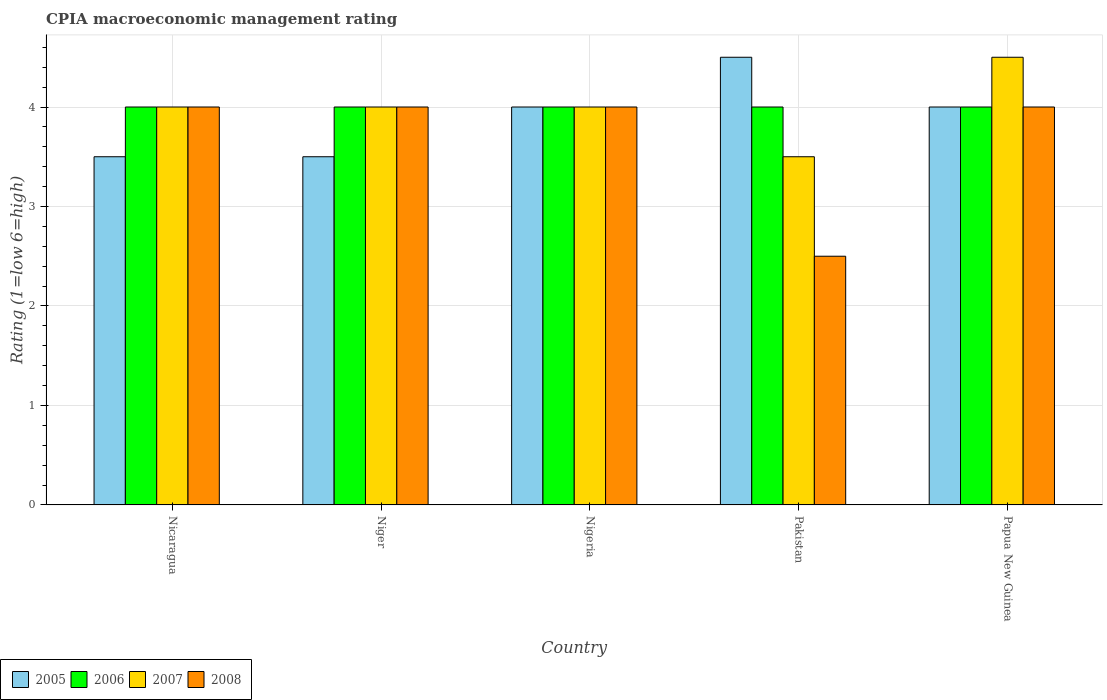How many different coloured bars are there?
Your answer should be compact. 4. How many groups of bars are there?
Provide a succinct answer. 5. Are the number of bars per tick equal to the number of legend labels?
Give a very brief answer. Yes. Are the number of bars on each tick of the X-axis equal?
Your answer should be very brief. Yes. How many bars are there on the 5th tick from the right?
Offer a terse response. 4. What is the label of the 5th group of bars from the left?
Offer a very short reply. Papua New Guinea. In which country was the CPIA rating in 2006 maximum?
Provide a succinct answer. Nicaragua. In how many countries, is the CPIA rating in 2006 greater than 4.4?
Ensure brevity in your answer.  0. What is the ratio of the CPIA rating in 2008 in Nicaragua to that in Papua New Guinea?
Provide a short and direct response. 1. What is the difference between the highest and the second highest CPIA rating in 2005?
Your answer should be compact. 0.5. What is the difference between the highest and the lowest CPIA rating in 2007?
Ensure brevity in your answer.  1. What does the 3rd bar from the left in Pakistan represents?
Give a very brief answer. 2007. Are all the bars in the graph horizontal?
Keep it short and to the point. No. Are the values on the major ticks of Y-axis written in scientific E-notation?
Your answer should be compact. No. How are the legend labels stacked?
Your answer should be compact. Horizontal. What is the title of the graph?
Provide a short and direct response. CPIA macroeconomic management rating. Does "1995" appear as one of the legend labels in the graph?
Offer a very short reply. No. What is the label or title of the Y-axis?
Provide a succinct answer. Rating (1=low 6=high). What is the Rating (1=low 6=high) in 2005 in Nicaragua?
Ensure brevity in your answer.  3.5. What is the Rating (1=low 6=high) of 2007 in Nicaragua?
Ensure brevity in your answer.  4. What is the Rating (1=low 6=high) of 2008 in Nicaragua?
Give a very brief answer. 4. What is the Rating (1=low 6=high) of 2007 in Niger?
Offer a terse response. 4. What is the Rating (1=low 6=high) in 2006 in Nigeria?
Keep it short and to the point. 4. What is the Rating (1=low 6=high) in 2007 in Nigeria?
Make the answer very short. 4. What is the Rating (1=low 6=high) in 2008 in Nigeria?
Your answer should be very brief. 4. What is the Rating (1=low 6=high) of 2005 in Pakistan?
Offer a terse response. 4.5. What is the Rating (1=low 6=high) of 2006 in Pakistan?
Offer a very short reply. 4. What is the Rating (1=low 6=high) in 2007 in Pakistan?
Make the answer very short. 3.5. What is the Rating (1=low 6=high) of 2007 in Papua New Guinea?
Provide a short and direct response. 4.5. Across all countries, what is the maximum Rating (1=low 6=high) in 2008?
Provide a short and direct response. 4. Across all countries, what is the minimum Rating (1=low 6=high) of 2005?
Your response must be concise. 3.5. Across all countries, what is the minimum Rating (1=low 6=high) of 2006?
Offer a terse response. 4. Across all countries, what is the minimum Rating (1=low 6=high) in 2008?
Offer a terse response. 2.5. What is the total Rating (1=low 6=high) in 2005 in the graph?
Keep it short and to the point. 19.5. What is the total Rating (1=low 6=high) in 2007 in the graph?
Keep it short and to the point. 20. What is the total Rating (1=low 6=high) of 2008 in the graph?
Make the answer very short. 18.5. What is the difference between the Rating (1=low 6=high) of 2005 in Nicaragua and that in Niger?
Offer a very short reply. 0. What is the difference between the Rating (1=low 6=high) in 2006 in Nicaragua and that in Niger?
Keep it short and to the point. 0. What is the difference between the Rating (1=low 6=high) of 2007 in Nicaragua and that in Niger?
Ensure brevity in your answer.  0. What is the difference between the Rating (1=low 6=high) of 2008 in Nicaragua and that in Niger?
Keep it short and to the point. 0. What is the difference between the Rating (1=low 6=high) in 2005 in Nicaragua and that in Nigeria?
Ensure brevity in your answer.  -0.5. What is the difference between the Rating (1=low 6=high) in 2006 in Nicaragua and that in Nigeria?
Make the answer very short. 0. What is the difference between the Rating (1=low 6=high) in 2007 in Nicaragua and that in Nigeria?
Keep it short and to the point. 0. What is the difference between the Rating (1=low 6=high) in 2008 in Nicaragua and that in Nigeria?
Give a very brief answer. 0. What is the difference between the Rating (1=low 6=high) in 2006 in Nicaragua and that in Papua New Guinea?
Offer a terse response. 0. What is the difference between the Rating (1=low 6=high) of 2008 in Niger and that in Pakistan?
Offer a very short reply. 1.5. What is the difference between the Rating (1=low 6=high) of 2005 in Niger and that in Papua New Guinea?
Give a very brief answer. -0.5. What is the difference between the Rating (1=low 6=high) in 2008 in Niger and that in Papua New Guinea?
Make the answer very short. 0. What is the difference between the Rating (1=low 6=high) of 2006 in Nigeria and that in Papua New Guinea?
Provide a succinct answer. 0. What is the difference between the Rating (1=low 6=high) of 2005 in Pakistan and that in Papua New Guinea?
Ensure brevity in your answer.  0.5. What is the difference between the Rating (1=low 6=high) of 2006 in Pakistan and that in Papua New Guinea?
Provide a succinct answer. 0. What is the difference between the Rating (1=low 6=high) of 2007 in Pakistan and that in Papua New Guinea?
Keep it short and to the point. -1. What is the difference between the Rating (1=low 6=high) in 2008 in Pakistan and that in Papua New Guinea?
Give a very brief answer. -1.5. What is the difference between the Rating (1=low 6=high) in 2005 in Nicaragua and the Rating (1=low 6=high) in 2006 in Niger?
Offer a very short reply. -0.5. What is the difference between the Rating (1=low 6=high) in 2005 in Nicaragua and the Rating (1=low 6=high) in 2008 in Niger?
Ensure brevity in your answer.  -0.5. What is the difference between the Rating (1=low 6=high) of 2006 in Nicaragua and the Rating (1=low 6=high) of 2008 in Niger?
Make the answer very short. 0. What is the difference between the Rating (1=low 6=high) of 2007 in Nicaragua and the Rating (1=low 6=high) of 2008 in Niger?
Your response must be concise. 0. What is the difference between the Rating (1=low 6=high) of 2005 in Nicaragua and the Rating (1=low 6=high) of 2006 in Pakistan?
Give a very brief answer. -0.5. What is the difference between the Rating (1=low 6=high) in 2005 in Nicaragua and the Rating (1=low 6=high) in 2008 in Pakistan?
Provide a short and direct response. 1. What is the difference between the Rating (1=low 6=high) of 2006 in Nicaragua and the Rating (1=low 6=high) of 2007 in Pakistan?
Give a very brief answer. 0.5. What is the difference between the Rating (1=low 6=high) of 2006 in Nicaragua and the Rating (1=low 6=high) of 2008 in Pakistan?
Give a very brief answer. 1.5. What is the difference between the Rating (1=low 6=high) of 2007 in Nicaragua and the Rating (1=low 6=high) of 2008 in Pakistan?
Provide a short and direct response. 1.5. What is the difference between the Rating (1=low 6=high) of 2005 in Nicaragua and the Rating (1=low 6=high) of 2007 in Papua New Guinea?
Provide a short and direct response. -1. What is the difference between the Rating (1=low 6=high) in 2005 in Nicaragua and the Rating (1=low 6=high) in 2008 in Papua New Guinea?
Offer a very short reply. -0.5. What is the difference between the Rating (1=low 6=high) in 2006 in Nicaragua and the Rating (1=low 6=high) in 2007 in Papua New Guinea?
Make the answer very short. -0.5. What is the difference between the Rating (1=low 6=high) of 2007 in Nicaragua and the Rating (1=low 6=high) of 2008 in Papua New Guinea?
Your answer should be compact. 0. What is the difference between the Rating (1=low 6=high) in 2005 in Niger and the Rating (1=low 6=high) in 2007 in Nigeria?
Your answer should be very brief. -0.5. What is the difference between the Rating (1=low 6=high) in 2005 in Niger and the Rating (1=low 6=high) in 2008 in Nigeria?
Offer a terse response. -0.5. What is the difference between the Rating (1=low 6=high) of 2006 in Niger and the Rating (1=low 6=high) of 2008 in Nigeria?
Provide a short and direct response. 0. What is the difference between the Rating (1=low 6=high) of 2007 in Niger and the Rating (1=low 6=high) of 2008 in Nigeria?
Your answer should be compact. 0. What is the difference between the Rating (1=low 6=high) of 2005 in Niger and the Rating (1=low 6=high) of 2007 in Pakistan?
Ensure brevity in your answer.  0. What is the difference between the Rating (1=low 6=high) in 2005 in Niger and the Rating (1=low 6=high) in 2008 in Pakistan?
Offer a terse response. 1. What is the difference between the Rating (1=low 6=high) in 2005 in Niger and the Rating (1=low 6=high) in 2006 in Papua New Guinea?
Offer a terse response. -0.5. What is the difference between the Rating (1=low 6=high) of 2005 in Niger and the Rating (1=low 6=high) of 2008 in Papua New Guinea?
Offer a terse response. -0.5. What is the difference between the Rating (1=low 6=high) of 2006 in Niger and the Rating (1=low 6=high) of 2008 in Papua New Guinea?
Offer a very short reply. 0. What is the difference between the Rating (1=low 6=high) of 2005 in Nigeria and the Rating (1=low 6=high) of 2006 in Pakistan?
Give a very brief answer. 0. What is the difference between the Rating (1=low 6=high) of 2005 in Nigeria and the Rating (1=low 6=high) of 2008 in Pakistan?
Offer a very short reply. 1.5. What is the difference between the Rating (1=low 6=high) of 2006 in Nigeria and the Rating (1=low 6=high) of 2007 in Pakistan?
Your answer should be compact. 0.5. What is the difference between the Rating (1=low 6=high) of 2006 in Nigeria and the Rating (1=low 6=high) of 2008 in Pakistan?
Make the answer very short. 1.5. What is the difference between the Rating (1=low 6=high) in 2005 in Nigeria and the Rating (1=low 6=high) in 2006 in Papua New Guinea?
Keep it short and to the point. 0. What is the difference between the Rating (1=low 6=high) of 2005 in Nigeria and the Rating (1=low 6=high) of 2007 in Papua New Guinea?
Your answer should be very brief. -0.5. What is the difference between the Rating (1=low 6=high) in 2005 in Nigeria and the Rating (1=low 6=high) in 2008 in Papua New Guinea?
Offer a very short reply. 0. What is the difference between the Rating (1=low 6=high) in 2005 in Pakistan and the Rating (1=low 6=high) in 2006 in Papua New Guinea?
Provide a succinct answer. 0.5. What is the difference between the Rating (1=low 6=high) in 2006 in Pakistan and the Rating (1=low 6=high) in 2007 in Papua New Guinea?
Your answer should be compact. -0.5. What is the difference between the Rating (1=low 6=high) of 2006 in Pakistan and the Rating (1=low 6=high) of 2008 in Papua New Guinea?
Make the answer very short. 0. What is the difference between the Rating (1=low 6=high) of 2007 in Pakistan and the Rating (1=low 6=high) of 2008 in Papua New Guinea?
Provide a short and direct response. -0.5. What is the average Rating (1=low 6=high) in 2005 per country?
Provide a short and direct response. 3.9. What is the average Rating (1=low 6=high) in 2006 per country?
Keep it short and to the point. 4. What is the difference between the Rating (1=low 6=high) in 2005 and Rating (1=low 6=high) in 2006 in Nicaragua?
Ensure brevity in your answer.  -0.5. What is the difference between the Rating (1=low 6=high) of 2005 and Rating (1=low 6=high) of 2008 in Nicaragua?
Provide a succinct answer. -0.5. What is the difference between the Rating (1=low 6=high) of 2006 and Rating (1=low 6=high) of 2008 in Nicaragua?
Make the answer very short. 0. What is the difference between the Rating (1=low 6=high) of 2007 and Rating (1=low 6=high) of 2008 in Nicaragua?
Your answer should be very brief. 0. What is the difference between the Rating (1=low 6=high) in 2005 and Rating (1=low 6=high) in 2006 in Niger?
Keep it short and to the point. -0.5. What is the difference between the Rating (1=low 6=high) of 2005 and Rating (1=low 6=high) of 2007 in Niger?
Make the answer very short. -0.5. What is the difference between the Rating (1=low 6=high) of 2005 and Rating (1=low 6=high) of 2006 in Nigeria?
Make the answer very short. 0. What is the difference between the Rating (1=low 6=high) in 2005 and Rating (1=low 6=high) in 2007 in Nigeria?
Provide a short and direct response. 0. What is the difference between the Rating (1=low 6=high) of 2006 and Rating (1=low 6=high) of 2008 in Nigeria?
Ensure brevity in your answer.  0. What is the difference between the Rating (1=low 6=high) in 2006 and Rating (1=low 6=high) in 2008 in Pakistan?
Your answer should be compact. 1.5. What is the difference between the Rating (1=low 6=high) of 2005 and Rating (1=low 6=high) of 2007 in Papua New Guinea?
Make the answer very short. -0.5. What is the difference between the Rating (1=low 6=high) in 2006 and Rating (1=low 6=high) in 2007 in Papua New Guinea?
Provide a short and direct response. -0.5. What is the difference between the Rating (1=low 6=high) in 2006 and Rating (1=low 6=high) in 2008 in Papua New Guinea?
Provide a succinct answer. 0. What is the difference between the Rating (1=low 6=high) in 2007 and Rating (1=low 6=high) in 2008 in Papua New Guinea?
Your answer should be very brief. 0.5. What is the ratio of the Rating (1=low 6=high) of 2005 in Nicaragua to that in Niger?
Provide a short and direct response. 1. What is the ratio of the Rating (1=low 6=high) of 2008 in Nicaragua to that in Niger?
Your answer should be compact. 1. What is the ratio of the Rating (1=low 6=high) of 2005 in Nicaragua to that in Pakistan?
Ensure brevity in your answer.  0.78. What is the ratio of the Rating (1=low 6=high) of 2006 in Nicaragua to that in Pakistan?
Keep it short and to the point. 1. What is the ratio of the Rating (1=low 6=high) of 2007 in Nicaragua to that in Pakistan?
Your answer should be compact. 1.14. What is the ratio of the Rating (1=low 6=high) of 2008 in Nicaragua to that in Pakistan?
Your answer should be very brief. 1.6. What is the ratio of the Rating (1=low 6=high) of 2005 in Niger to that in Nigeria?
Provide a succinct answer. 0.88. What is the ratio of the Rating (1=low 6=high) in 2006 in Niger to that in Nigeria?
Your answer should be compact. 1. What is the ratio of the Rating (1=low 6=high) of 2008 in Niger to that in Nigeria?
Provide a succinct answer. 1. What is the ratio of the Rating (1=low 6=high) in 2007 in Niger to that in Pakistan?
Your response must be concise. 1.14. What is the ratio of the Rating (1=low 6=high) of 2006 in Niger to that in Papua New Guinea?
Offer a terse response. 1. What is the ratio of the Rating (1=low 6=high) in 2007 in Niger to that in Papua New Guinea?
Provide a succinct answer. 0.89. What is the ratio of the Rating (1=low 6=high) in 2008 in Niger to that in Papua New Guinea?
Provide a succinct answer. 1. What is the ratio of the Rating (1=low 6=high) in 2005 in Nigeria to that in Pakistan?
Give a very brief answer. 0.89. What is the ratio of the Rating (1=low 6=high) of 2006 in Nigeria to that in Pakistan?
Your response must be concise. 1. What is the ratio of the Rating (1=low 6=high) in 2008 in Nigeria to that in Pakistan?
Provide a succinct answer. 1.6. What is the ratio of the Rating (1=low 6=high) in 2005 in Nigeria to that in Papua New Guinea?
Keep it short and to the point. 1. What is the ratio of the Rating (1=low 6=high) of 2006 in Nigeria to that in Papua New Guinea?
Offer a terse response. 1. What is the ratio of the Rating (1=low 6=high) of 2007 in Nigeria to that in Papua New Guinea?
Provide a succinct answer. 0.89. What is the ratio of the Rating (1=low 6=high) in 2008 in Nigeria to that in Papua New Guinea?
Provide a short and direct response. 1. What is the ratio of the Rating (1=low 6=high) in 2007 in Pakistan to that in Papua New Guinea?
Your answer should be very brief. 0.78. What is the difference between the highest and the second highest Rating (1=low 6=high) of 2005?
Offer a terse response. 0.5. What is the difference between the highest and the second highest Rating (1=low 6=high) in 2007?
Your answer should be very brief. 0.5. What is the difference between the highest and the second highest Rating (1=low 6=high) of 2008?
Your answer should be very brief. 0. What is the difference between the highest and the lowest Rating (1=low 6=high) of 2005?
Provide a short and direct response. 1. 